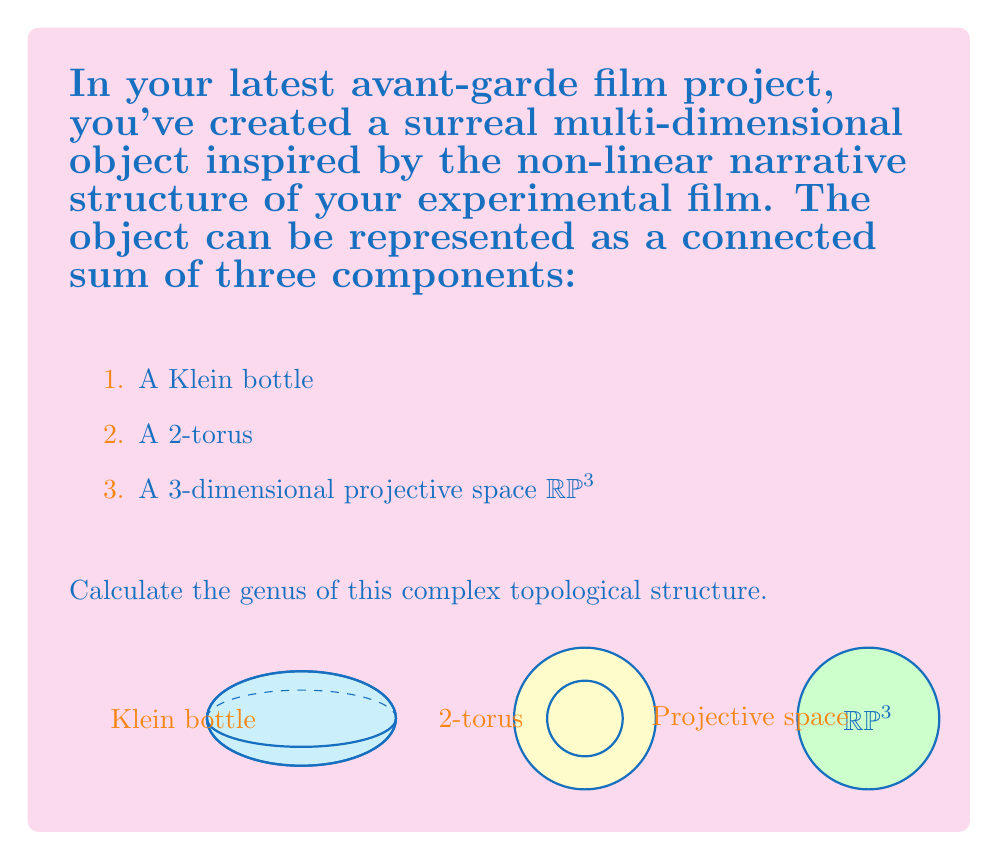Could you help me with this problem? To solve this problem, we need to follow these steps:

1) Recall the formula for the genus of a connected sum:
   $$ g(M_1 \# M_2) = g(M_1) + g(M_2) $$
   where $g$ denotes the genus and $\#$ denotes the connected sum.

2) For our object, we have:
   $$ g(\text{Object}) = g(\text{Klein bottle} \# \text{2-torus} \# \text{RP}³) $$

3) Let's consider each component:

   a) Klein bottle: The genus of a Klein bottle is 2.
      $g(\text{Klein bottle}) = 2$

   b) 2-torus: The genus of a 2-torus (double torus) is 2.
      $g(\text{2-torus}) = 2$

   c) RP³: The 3-dimensional projective space is not a 2-manifold, so it doesn't have a genus in the traditional sense. However, we can consider its contribution to the overall genus by looking at its Euler characteristic.

      The Euler characteristic of RP³ is $\chi(\text{RP}³) = 1$.

      For orientable surfaces, the relationship between genus and Euler characteristic is:
      $$ \chi = 2 - 2g $$

      Solving for g:
      $$ g = 1 - \frac{\chi}{2} $$

      Therefore, the contribution of RP³ to the genus is:
      $$ g(\text{RP}³) = 1 - \frac{1}{2} = \frac{1}{2} $$

4) Now, we can sum up the genera:
   $$ g(\text{Object}) = g(\text{Klein bottle}) + g(\text{2-torus}) + g(\text{RP}³) $$
   $$ g(\text{Object}) = 2 + 2 + \frac{1}{2} = \frac{9}{2} $$

Therefore, the genus of the complex topological structure is 4.5.
Answer: $\frac{9}{2}$ or 4.5 